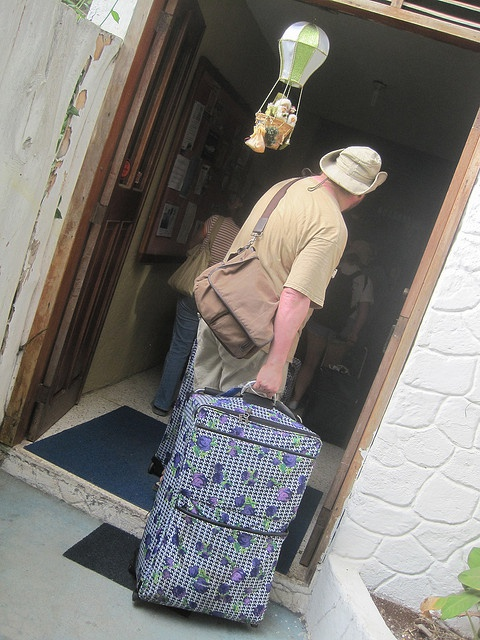Describe the objects in this image and their specific colors. I can see suitcase in darkgray, gray, and black tones, people in darkgray, tan, and gray tones, handbag in darkgray, tan, and gray tones, people in darkgray, black, and gray tones, and people in darkgray, black, and gray tones in this image. 